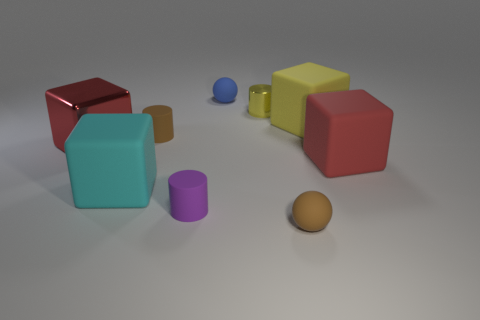The object that is the same color as the small shiny cylinder is what size?
Your answer should be compact. Large. There is a object to the left of the cyan matte thing; what is its size?
Provide a short and direct response. Large. There is a big red block that is behind the big red object in front of the large red metal thing; what is its material?
Your response must be concise. Metal. Are the red cube on the right side of the yellow rubber block and the large red cube behind the large red rubber cube made of the same material?
Make the answer very short. No. Is the number of shiny things behind the metallic block greater than the number of cyan balls?
Ensure brevity in your answer.  Yes. There is a small brown thing that is left of the small rubber ball behind the small brown rubber thing behind the cyan object; what is its shape?
Keep it short and to the point. Cylinder. There is a large red shiny thing that is in front of the brown cylinder; does it have the same shape as the large matte object in front of the big red matte cube?
Offer a terse response. Yes. How many spheres are large cyan objects or red shiny things?
Give a very brief answer. 0. Are the cyan thing and the yellow cylinder made of the same material?
Offer a very short reply. No. There is a red thing that is to the right of the tiny metallic cylinder; what shape is it?
Your response must be concise. Cube. 